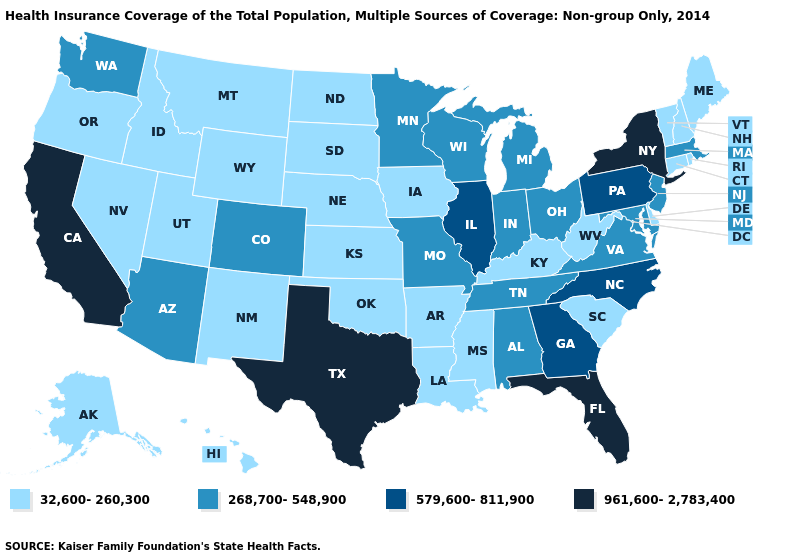Among the states that border Virginia , does Kentucky have the lowest value?
Give a very brief answer. Yes. What is the lowest value in states that border North Dakota?
Short answer required. 32,600-260,300. Among the states that border Iowa , which have the highest value?
Quick response, please. Illinois. Among the states that border Missouri , which have the highest value?
Short answer required. Illinois. What is the value of Washington?
Answer briefly. 268,700-548,900. What is the lowest value in the South?
Give a very brief answer. 32,600-260,300. Which states have the lowest value in the USA?
Write a very short answer. Alaska, Arkansas, Connecticut, Delaware, Hawaii, Idaho, Iowa, Kansas, Kentucky, Louisiana, Maine, Mississippi, Montana, Nebraska, Nevada, New Hampshire, New Mexico, North Dakota, Oklahoma, Oregon, Rhode Island, South Carolina, South Dakota, Utah, Vermont, West Virginia, Wyoming. Which states have the highest value in the USA?
Concise answer only. California, Florida, New York, Texas. Does Massachusetts have the lowest value in the USA?
Quick response, please. No. Does Texas have the highest value in the South?
Write a very short answer. Yes. Does Wisconsin have the lowest value in the USA?
Write a very short answer. No. Which states hav the highest value in the West?
Give a very brief answer. California. Name the states that have a value in the range 579,600-811,900?
Quick response, please. Georgia, Illinois, North Carolina, Pennsylvania. Among the states that border Virginia , which have the highest value?
Quick response, please. North Carolina. Among the states that border Illinois , which have the highest value?
Quick response, please. Indiana, Missouri, Wisconsin. 